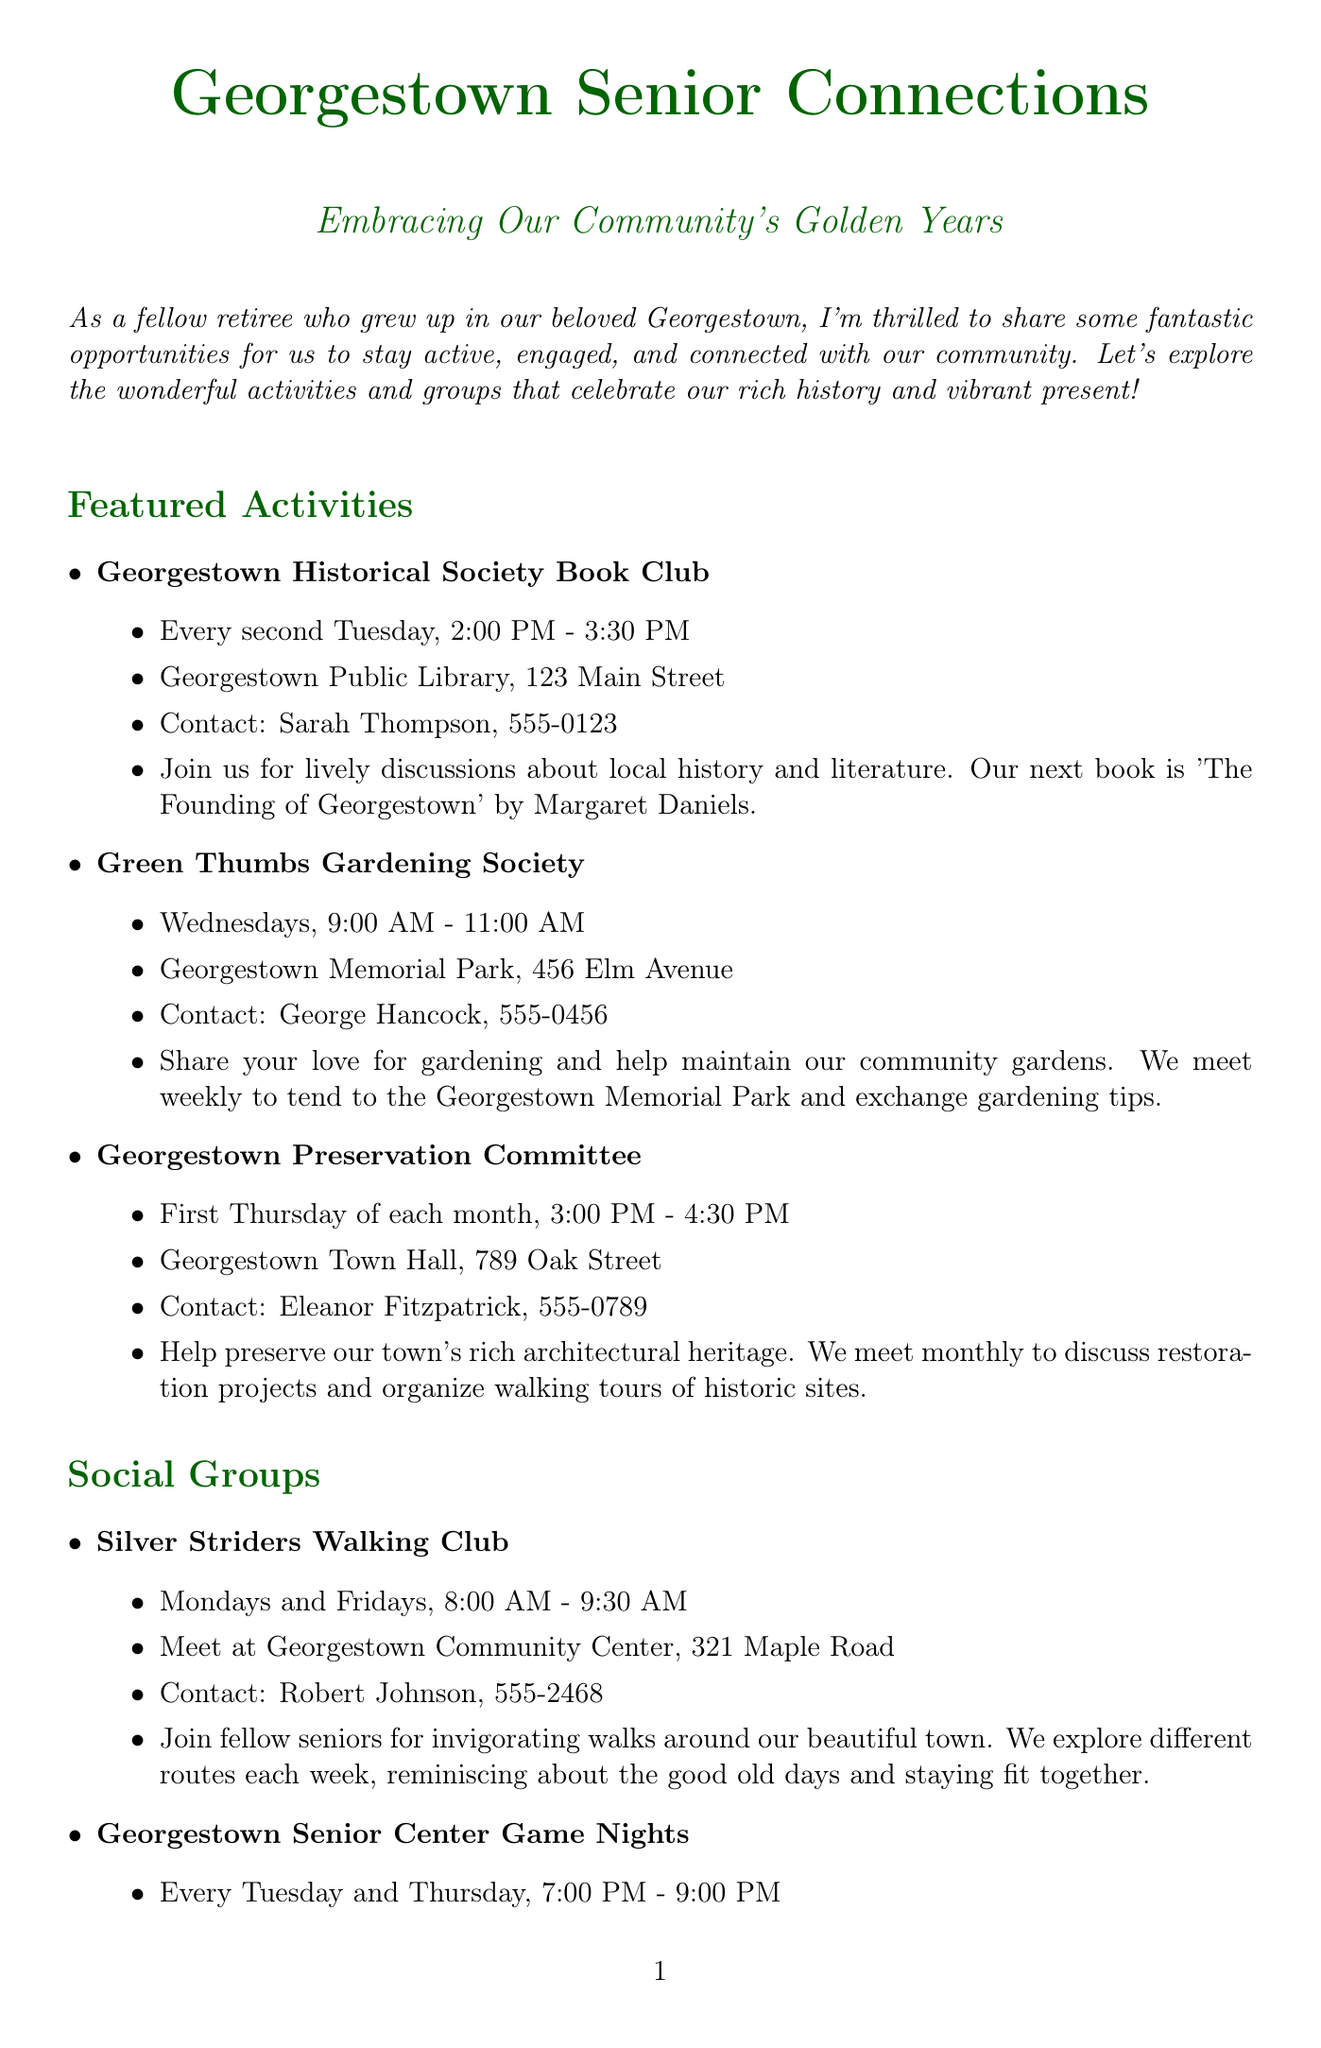What is the title of the newsletter? The title of the newsletter is stated at the beginning of the document as "Georgestown Senior Connections."
Answer: Georgestown Senior Connections Who is the contact for the Georgestown Historical Society Book Club? The contact information for the book club is listed in its description.
Answer: Sarah Thompson, 555-0123 What day does the Green Thumbs Gardening Society meet? The document specifies that this society meets on Wednesdays.
Answer: Wednesdays When is the next meeting of the Georgestown Preservation Committee? The meeting schedule indicates it is on the first Thursday of each month.
Answer: First Thursday of each month What time does the Silver Striders Walking Club start? The document provides the starting time for the walking club meetings.
Answer: 8:00 AM How often do the Georgestown Senior Center Game Nights occur? The frequency of the game nights is specified in the document.
Answer: Twice a week What is the date of the Annual Georgestown Heritage Day Celebration? The document contains the specific date for the special event.
Answer: Saturday, September 15th What activity requires participants to help maintain community gardens? The activity focused on community gardens is explicitly mentioned in the document.
Answer: Green Thumbs Gardening Society What is emphasized as key to a happy retirement? The document concludes with a specific sentiment regarding retirement engagement.
Answer: Staying engaged 